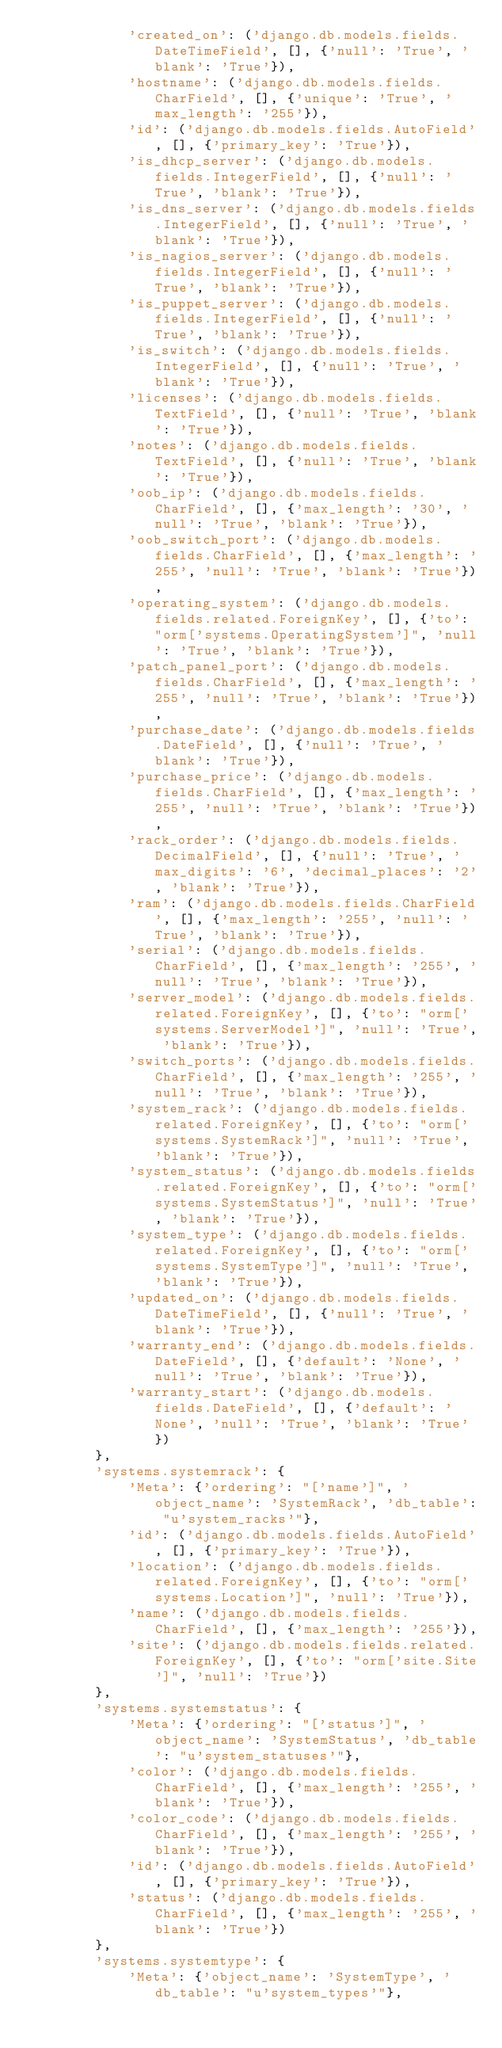<code> <loc_0><loc_0><loc_500><loc_500><_Python_>            'created_on': ('django.db.models.fields.DateTimeField', [], {'null': 'True', 'blank': 'True'}),
            'hostname': ('django.db.models.fields.CharField', [], {'unique': 'True', 'max_length': '255'}),
            'id': ('django.db.models.fields.AutoField', [], {'primary_key': 'True'}),
            'is_dhcp_server': ('django.db.models.fields.IntegerField', [], {'null': 'True', 'blank': 'True'}),
            'is_dns_server': ('django.db.models.fields.IntegerField', [], {'null': 'True', 'blank': 'True'}),
            'is_nagios_server': ('django.db.models.fields.IntegerField', [], {'null': 'True', 'blank': 'True'}),
            'is_puppet_server': ('django.db.models.fields.IntegerField', [], {'null': 'True', 'blank': 'True'}),
            'is_switch': ('django.db.models.fields.IntegerField', [], {'null': 'True', 'blank': 'True'}),
            'licenses': ('django.db.models.fields.TextField', [], {'null': 'True', 'blank': 'True'}),
            'notes': ('django.db.models.fields.TextField', [], {'null': 'True', 'blank': 'True'}),
            'oob_ip': ('django.db.models.fields.CharField', [], {'max_length': '30', 'null': 'True', 'blank': 'True'}),
            'oob_switch_port': ('django.db.models.fields.CharField', [], {'max_length': '255', 'null': 'True', 'blank': 'True'}),
            'operating_system': ('django.db.models.fields.related.ForeignKey', [], {'to': "orm['systems.OperatingSystem']", 'null': 'True', 'blank': 'True'}),
            'patch_panel_port': ('django.db.models.fields.CharField', [], {'max_length': '255', 'null': 'True', 'blank': 'True'}),
            'purchase_date': ('django.db.models.fields.DateField', [], {'null': 'True', 'blank': 'True'}),
            'purchase_price': ('django.db.models.fields.CharField', [], {'max_length': '255', 'null': 'True', 'blank': 'True'}),
            'rack_order': ('django.db.models.fields.DecimalField', [], {'null': 'True', 'max_digits': '6', 'decimal_places': '2', 'blank': 'True'}),
            'ram': ('django.db.models.fields.CharField', [], {'max_length': '255', 'null': 'True', 'blank': 'True'}),
            'serial': ('django.db.models.fields.CharField', [], {'max_length': '255', 'null': 'True', 'blank': 'True'}),
            'server_model': ('django.db.models.fields.related.ForeignKey', [], {'to': "orm['systems.ServerModel']", 'null': 'True', 'blank': 'True'}),
            'switch_ports': ('django.db.models.fields.CharField', [], {'max_length': '255', 'null': 'True', 'blank': 'True'}),
            'system_rack': ('django.db.models.fields.related.ForeignKey', [], {'to': "orm['systems.SystemRack']", 'null': 'True', 'blank': 'True'}),
            'system_status': ('django.db.models.fields.related.ForeignKey', [], {'to': "orm['systems.SystemStatus']", 'null': 'True', 'blank': 'True'}),
            'system_type': ('django.db.models.fields.related.ForeignKey', [], {'to': "orm['systems.SystemType']", 'null': 'True', 'blank': 'True'}),
            'updated_on': ('django.db.models.fields.DateTimeField', [], {'null': 'True', 'blank': 'True'}),
            'warranty_end': ('django.db.models.fields.DateField', [], {'default': 'None', 'null': 'True', 'blank': 'True'}),
            'warranty_start': ('django.db.models.fields.DateField', [], {'default': 'None', 'null': 'True', 'blank': 'True'})
        },
        'systems.systemrack': {
            'Meta': {'ordering': "['name']", 'object_name': 'SystemRack', 'db_table': "u'system_racks'"},
            'id': ('django.db.models.fields.AutoField', [], {'primary_key': 'True'}),
            'location': ('django.db.models.fields.related.ForeignKey', [], {'to': "orm['systems.Location']", 'null': 'True'}),
            'name': ('django.db.models.fields.CharField', [], {'max_length': '255'}),
            'site': ('django.db.models.fields.related.ForeignKey', [], {'to': "orm['site.Site']", 'null': 'True'})
        },
        'systems.systemstatus': {
            'Meta': {'ordering': "['status']", 'object_name': 'SystemStatus', 'db_table': "u'system_statuses'"},
            'color': ('django.db.models.fields.CharField', [], {'max_length': '255', 'blank': 'True'}),
            'color_code': ('django.db.models.fields.CharField', [], {'max_length': '255', 'blank': 'True'}),
            'id': ('django.db.models.fields.AutoField', [], {'primary_key': 'True'}),
            'status': ('django.db.models.fields.CharField', [], {'max_length': '255', 'blank': 'True'})
        },
        'systems.systemtype': {
            'Meta': {'object_name': 'SystemType', 'db_table': "u'system_types'"},</code> 